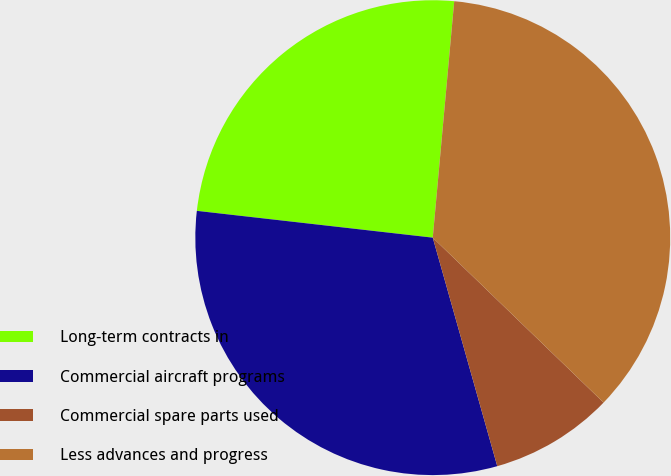Convert chart. <chart><loc_0><loc_0><loc_500><loc_500><pie_chart><fcel>Long-term contracts in<fcel>Commercial aircraft programs<fcel>Commercial spare parts used<fcel>Less advances and progress<nl><fcel>24.64%<fcel>31.18%<fcel>8.4%<fcel>35.78%<nl></chart> 